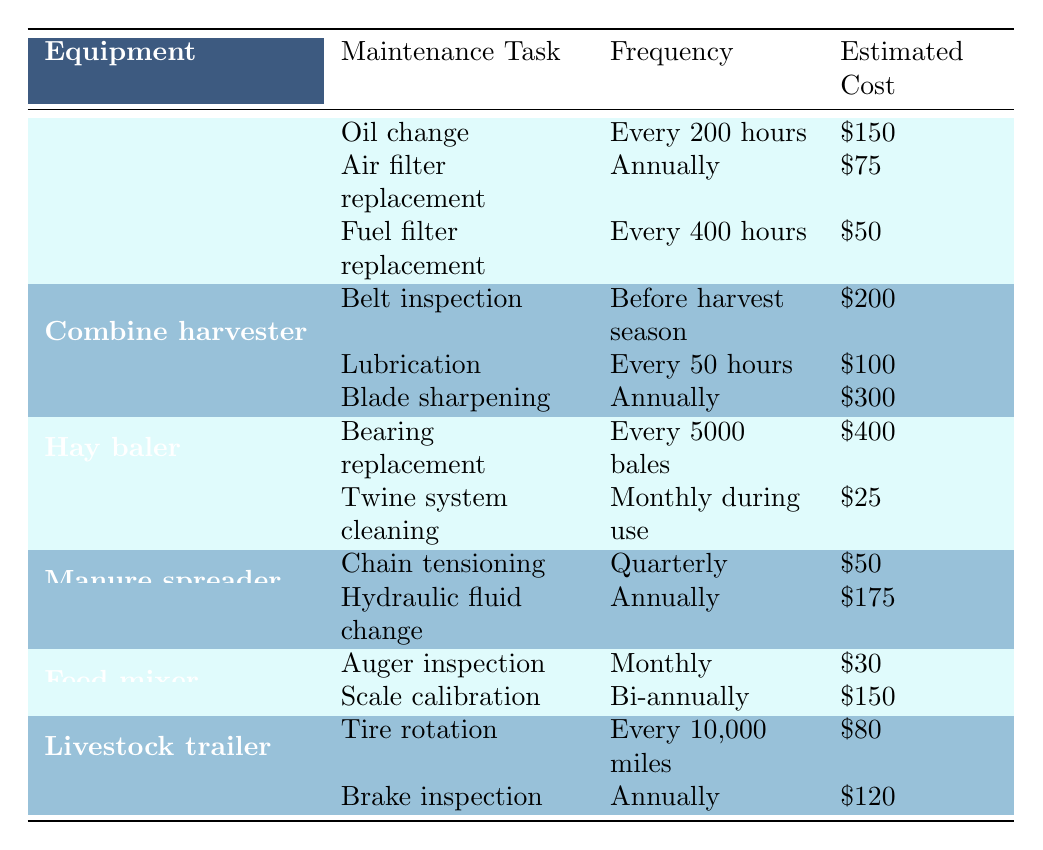What is the estimated cost for an oil change on a tractor? The table states that an oil change for a tractor has an estimated cost of $150.
Answer: $150 How often do you need to replace the fuel filter on a tractor? According to the table, the fuel filter replacement on a tractor is required every 400 hours.
Answer: Every 400 hours What is the total estimated cost for the annual maintenance tasks of the combine harvester? The annual maintenance tasks for the combine harvester are blade sharpening ($300) and lubrication ($100). Adding these costs gives us $300 + $100 = $400 for annual maintenance.
Answer: $400 Is lubrication for the combine harvester needed after every harvest season? The table indicates that lubrication for the combine harvester is required every 50 hours, not specifically after the harvest season. Therefore, it is not accurate to say it is needed after each harvest.
Answer: No Which equipment requires maintenance every 10,000 miles? The table shows that the livestock trailer requires tire rotation every 10,000 miles.
Answer: Livestock trailer 